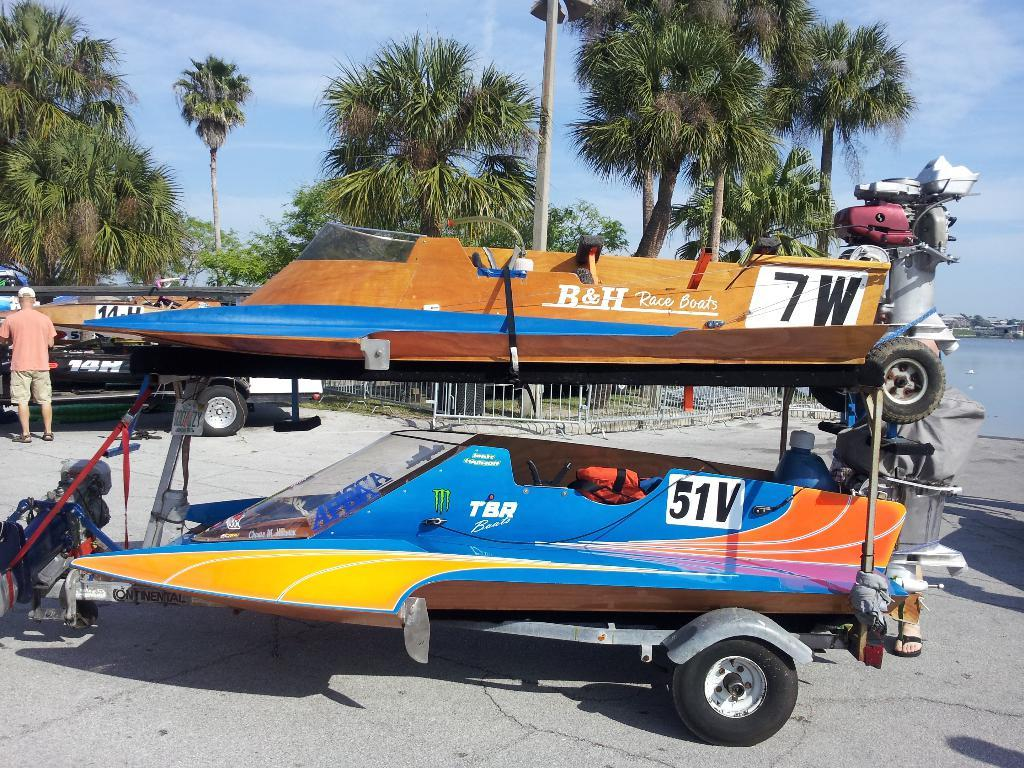Provide a one-sentence caption for the provided image. A pair of ski boats on one trailer labeled 51v and 7w. 